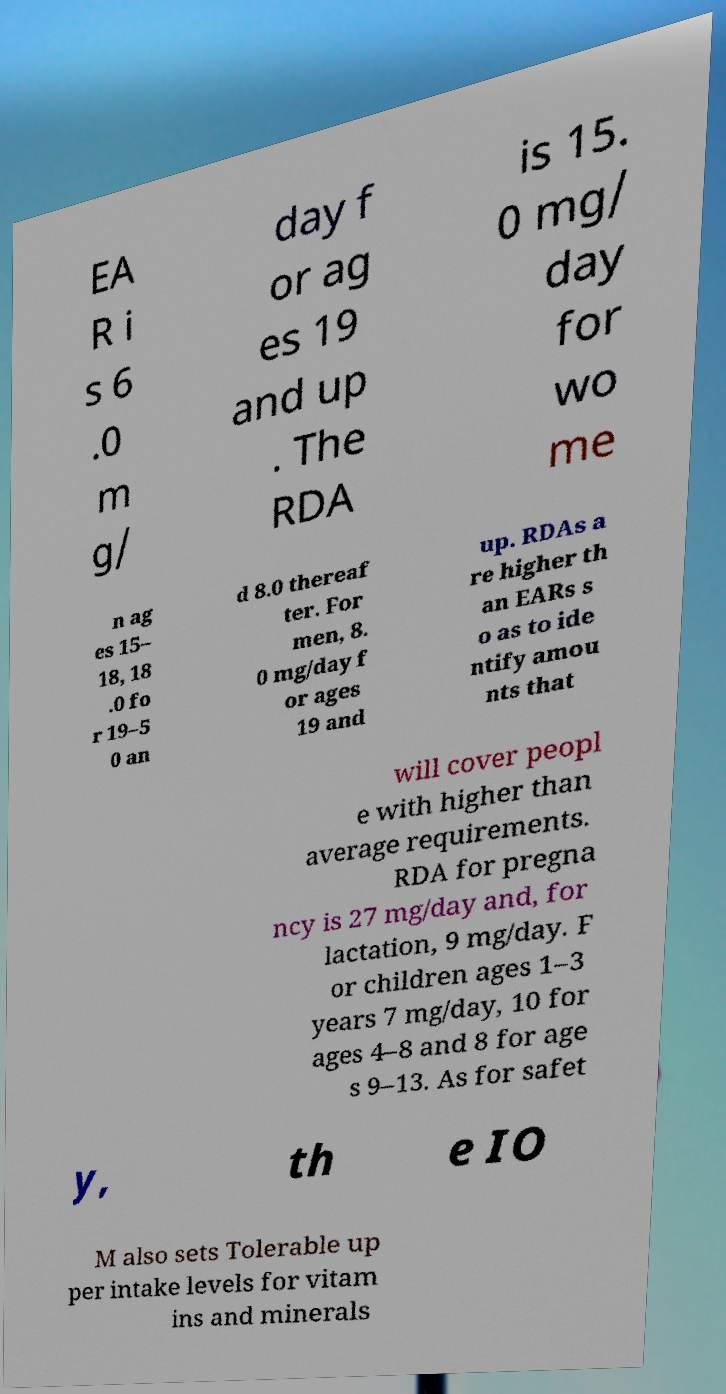I need the written content from this picture converted into text. Can you do that? EA R i s 6 .0 m g/ day f or ag es 19 and up . The RDA is 15. 0 mg/ day for wo me n ag es 15– 18, 18 .0 fo r 19–5 0 an d 8.0 thereaf ter. For men, 8. 0 mg/day f or ages 19 and up. RDAs a re higher th an EARs s o as to ide ntify amou nts that will cover peopl e with higher than average requirements. RDA for pregna ncy is 27 mg/day and, for lactation, 9 mg/day. F or children ages 1–3 years 7 mg/day, 10 for ages 4–8 and 8 for age s 9–13. As for safet y, th e IO M also sets Tolerable up per intake levels for vitam ins and minerals 